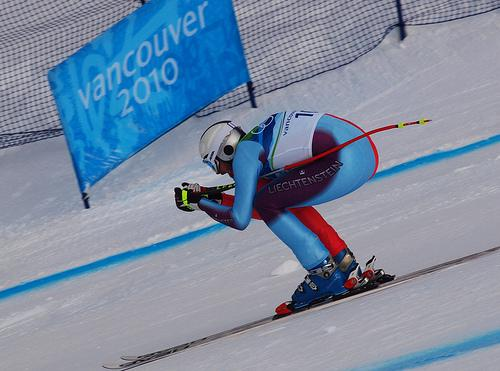Question: what activity is shown?
Choices:
A. Biking.
B. Skiing.
C. Motorcycling.
D. Surfing.
Answer with the letter. Answer: B Question: why is he crouching?
Choices:
A. He is hurt.
B. Speed.
C. He is crying.
D. He is laughing.
Answer with the letter. Answer: B Question: who is there?
Choices:
A. The man.
B. The woman.
C. The child.
D. Skier.
Answer with the letter. Answer: D Question: what is in the background?
Choices:
A. Sign.
B. Stop sign.
C. Traffic light.
D. Billboard.
Answer with the letter. Answer: A Question: what is on the sign?
Choices:
A. Vancouver 2010.
B. Super Bowl 2015.
C. Super Bowl 2014.
D. Super Bowl 2013.
Answer with the letter. Answer: A Question: where is this scene?
Choices:
A. Usa.
B. Canada.
C. Jamaica.
D. Korea.
Answer with the letter. Answer: B 